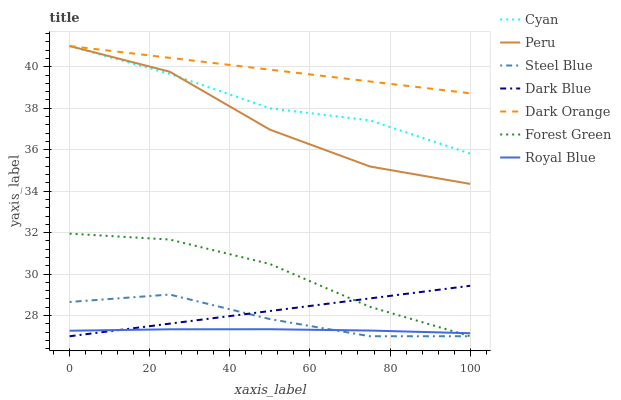Does Royal Blue have the minimum area under the curve?
Answer yes or no. Yes. Does Dark Orange have the maximum area under the curve?
Answer yes or no. Yes. Does Steel Blue have the minimum area under the curve?
Answer yes or no. No. Does Steel Blue have the maximum area under the curve?
Answer yes or no. No. Is Dark Blue the smoothest?
Answer yes or no. Yes. Is Peru the roughest?
Answer yes or no. Yes. Is Royal Blue the smoothest?
Answer yes or no. No. Is Royal Blue the roughest?
Answer yes or no. No. Does Steel Blue have the lowest value?
Answer yes or no. Yes. Does Royal Blue have the lowest value?
Answer yes or no. No. Does Cyan have the highest value?
Answer yes or no. Yes. Does Steel Blue have the highest value?
Answer yes or no. No. Is Forest Green less than Peru?
Answer yes or no. Yes. Is Cyan greater than Royal Blue?
Answer yes or no. Yes. Does Dark Orange intersect Cyan?
Answer yes or no. Yes. Is Dark Orange less than Cyan?
Answer yes or no. No. Is Dark Orange greater than Cyan?
Answer yes or no. No. Does Forest Green intersect Peru?
Answer yes or no. No. 